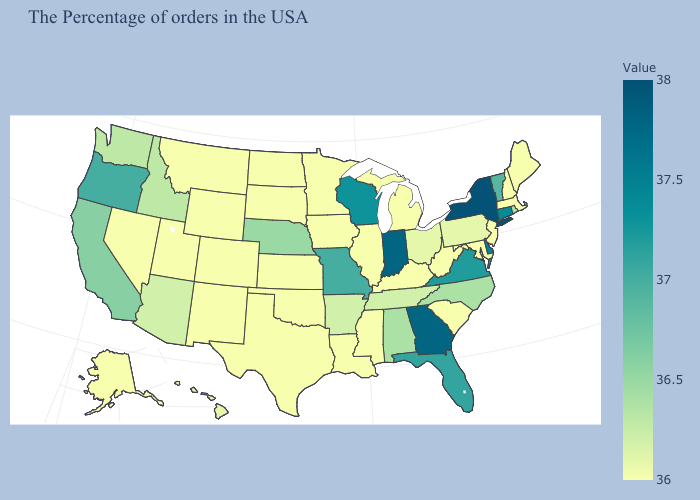Which states hav the highest value in the South?
Concise answer only. Georgia. Is the legend a continuous bar?
Concise answer only. Yes. Does New York have the highest value in the USA?
Keep it brief. Yes. Does Texas have the highest value in the South?
Quick response, please. No. Does Alaska have the lowest value in the West?
Keep it brief. Yes. Does Utah have a lower value than North Carolina?
Concise answer only. Yes. 